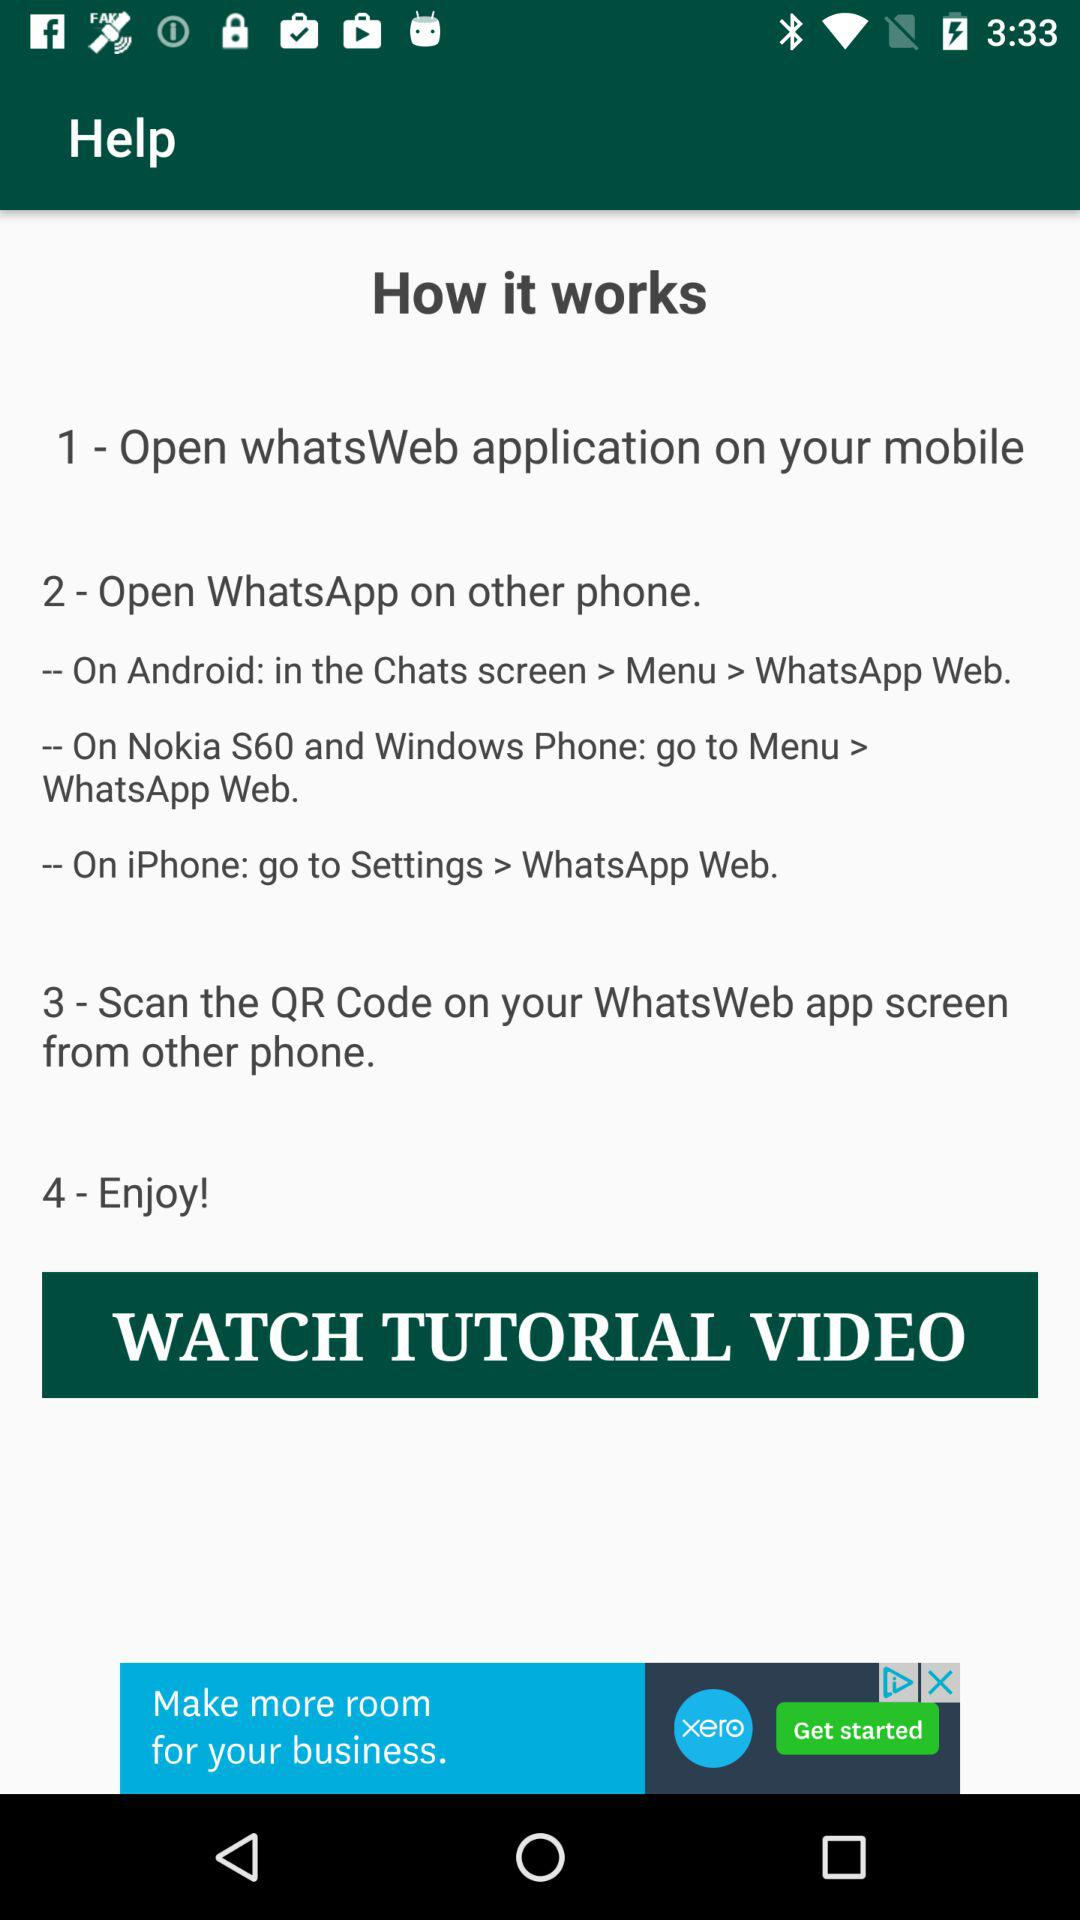How many steps are there in the process?
Answer the question using a single word or phrase. 4 